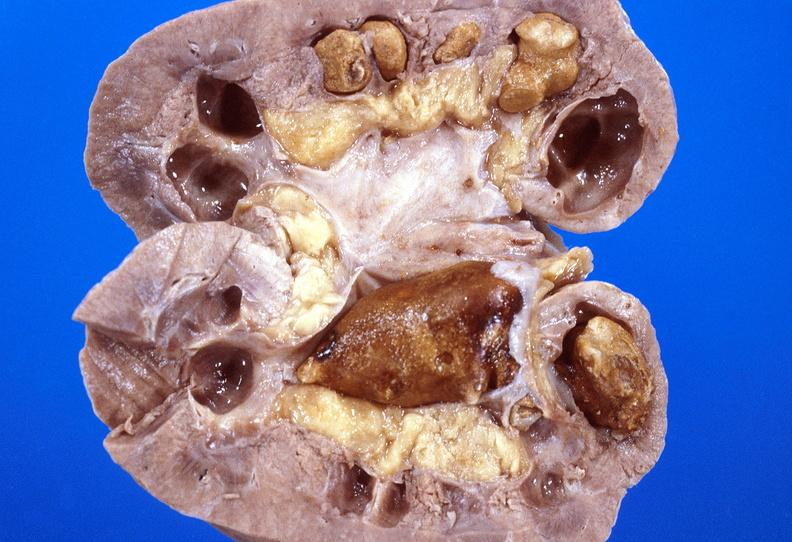where is this?
Answer the question using a single word or phrase. Urinary 